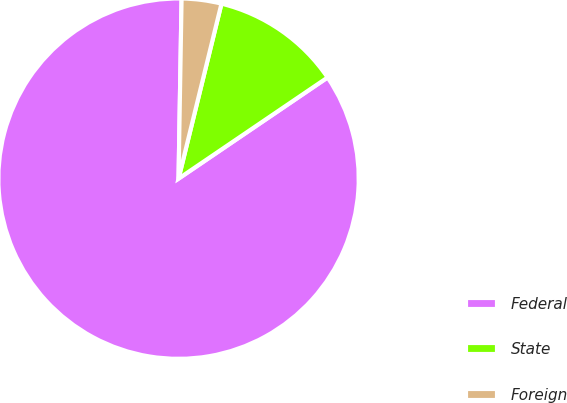Convert chart to OTSL. <chart><loc_0><loc_0><loc_500><loc_500><pie_chart><fcel>Federal<fcel>State<fcel>Foreign<nl><fcel>84.77%<fcel>11.68%<fcel>3.56%<nl></chart> 